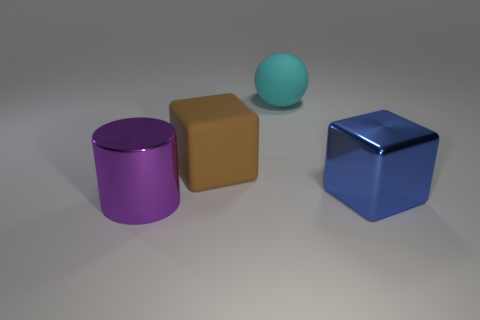Add 2 big metallic objects. How many objects exist? 6 Subtract 0 green cylinders. How many objects are left? 4 Subtract all cylinders. How many objects are left? 3 Subtract all brown cylinders. Subtract all blue cubes. How many cylinders are left? 1 Subtract all big blue rubber cylinders. Subtract all purple things. How many objects are left? 3 Add 3 cyan rubber spheres. How many cyan rubber spheres are left? 4 Add 4 large metal cubes. How many large metal cubes exist? 5 